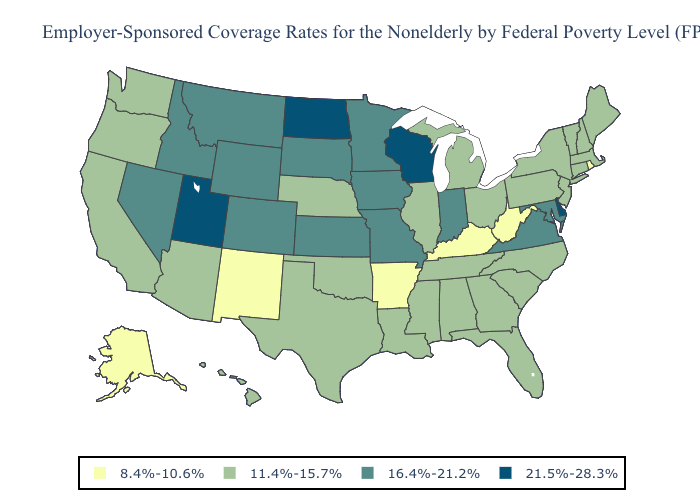Name the states that have a value in the range 16.4%-21.2%?
Quick response, please. Colorado, Idaho, Indiana, Iowa, Kansas, Maryland, Minnesota, Missouri, Montana, Nevada, South Dakota, Virginia, Wyoming. Does the first symbol in the legend represent the smallest category?
Answer briefly. Yes. Name the states that have a value in the range 8.4%-10.6%?
Quick response, please. Alaska, Arkansas, Kentucky, New Mexico, Rhode Island, West Virginia. Does California have the same value as Alaska?
Short answer required. No. Name the states that have a value in the range 8.4%-10.6%?
Short answer required. Alaska, Arkansas, Kentucky, New Mexico, Rhode Island, West Virginia. How many symbols are there in the legend?
Concise answer only. 4. What is the value of Oregon?
Give a very brief answer. 11.4%-15.7%. Name the states that have a value in the range 21.5%-28.3%?
Keep it brief. Delaware, North Dakota, Utah, Wisconsin. Name the states that have a value in the range 21.5%-28.3%?
Quick response, please. Delaware, North Dakota, Utah, Wisconsin. Name the states that have a value in the range 11.4%-15.7%?
Answer briefly. Alabama, Arizona, California, Connecticut, Florida, Georgia, Hawaii, Illinois, Louisiana, Maine, Massachusetts, Michigan, Mississippi, Nebraska, New Hampshire, New Jersey, New York, North Carolina, Ohio, Oklahoma, Oregon, Pennsylvania, South Carolina, Tennessee, Texas, Vermont, Washington. Among the states that border South Dakota , does Nebraska have the lowest value?
Concise answer only. Yes. What is the highest value in the USA?
Short answer required. 21.5%-28.3%. Which states hav the highest value in the Northeast?
Short answer required. Connecticut, Maine, Massachusetts, New Hampshire, New Jersey, New York, Pennsylvania, Vermont. Which states have the lowest value in the MidWest?
Give a very brief answer. Illinois, Michigan, Nebraska, Ohio. 